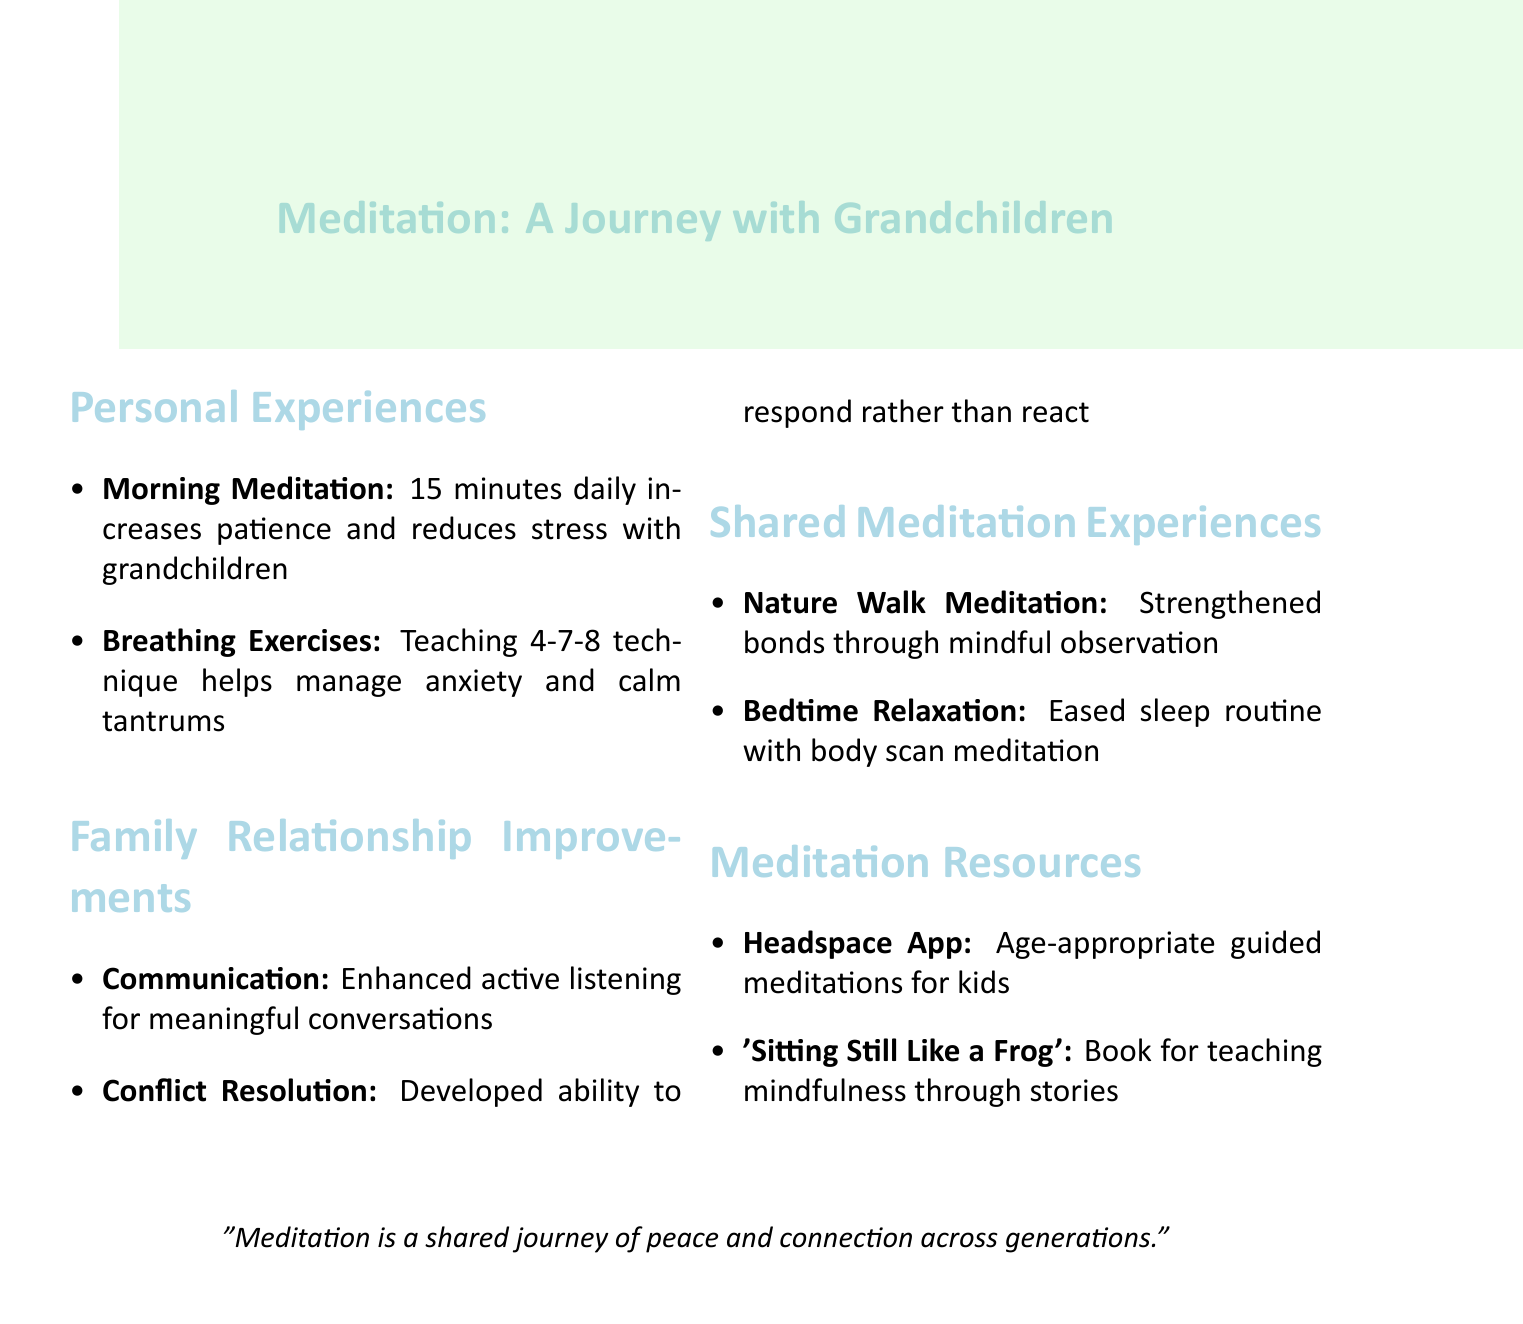what is the title of the first personal experience entry? The title of the first personal experience entry is "Morning Meditation Routine."
Answer: Morning Meditation Routine how long is the morning meditation routine? The document states that the morning meditation routine lasts for 15 minutes.
Answer: 15 minutes what breathing technique is mentioned in the notes? The breathing technique mentioned in the notes is the 4-7-8 technique.
Answer: 4-7-8 how has meditation improved communication within the family? The document indicates that meditation has enhanced active listening skills leading to more meaningful conversations.
Answer: Enhanced active listening skills which activity helped ease bedtime for grandchildren? The activity that assisted with easing bedtime is body scan meditation.
Answer: Body scan meditation what app was introduced to the grandchildren for guided meditations? The app mentioned for guided meditations is the Headspace App.
Answer: Headspace App how did the Nature Walk Meditation strengthen family bonds? The Nature Walk Meditation strengthened bonds through mindful observation of nature.
Answer: Mindful observation what is a specific resource used to teach mindfulness concepts? The book used to teach mindfulness concepts is "Sitting Still Like a Frog" by Eline Snel.
Answer: Sitting Still Like a Frog what significant skill has been developed for conflict resolution? The document states that the ability to respond rather than react has been developed for conflict resolution.
Answer: Respond rather than react 